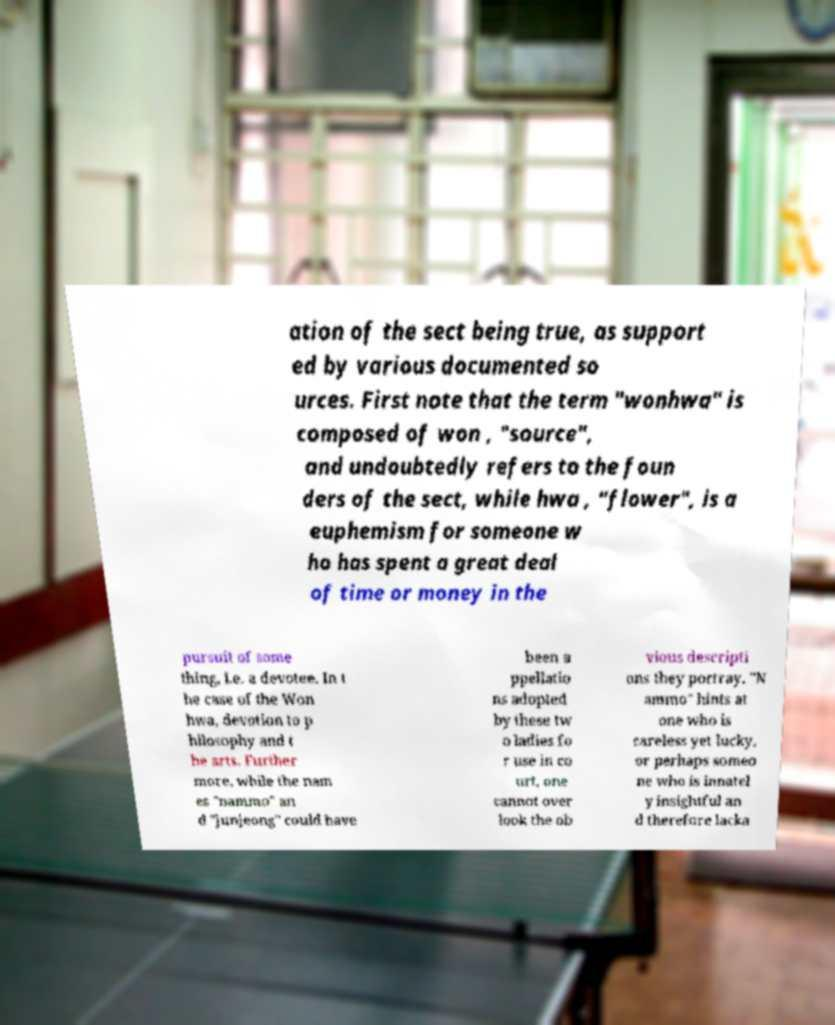I need the written content from this picture converted into text. Can you do that? ation of the sect being true, as support ed by various documented so urces. First note that the term "wonhwa" is composed of won , "source", and undoubtedly refers to the foun ders of the sect, while hwa , "flower", is a euphemism for someone w ho has spent a great deal of time or money in the pursuit of some thing, i.e. a devotee. In t he case of the Won hwa, devotion to p hilosophy and t he arts. Further more, while the nam es "nammo" an d "junjeong" could have been a ppellatio ns adopted by these tw o ladies fo r use in co urt, one cannot over look the ob vious descripti ons they portray. "N ammo" hints at one who is careless yet lucky, or perhaps someo ne who is innatel y insightful an d therefore lacka 